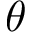<formula> <loc_0><loc_0><loc_500><loc_500>\theta</formula> 